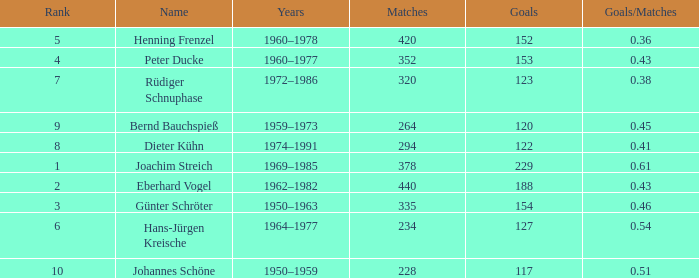What average goals have matches less than 228? None. 